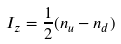<formula> <loc_0><loc_0><loc_500><loc_500>I _ { z } = { \frac { 1 } { 2 } } ( n _ { u } - n _ { d } )</formula> 